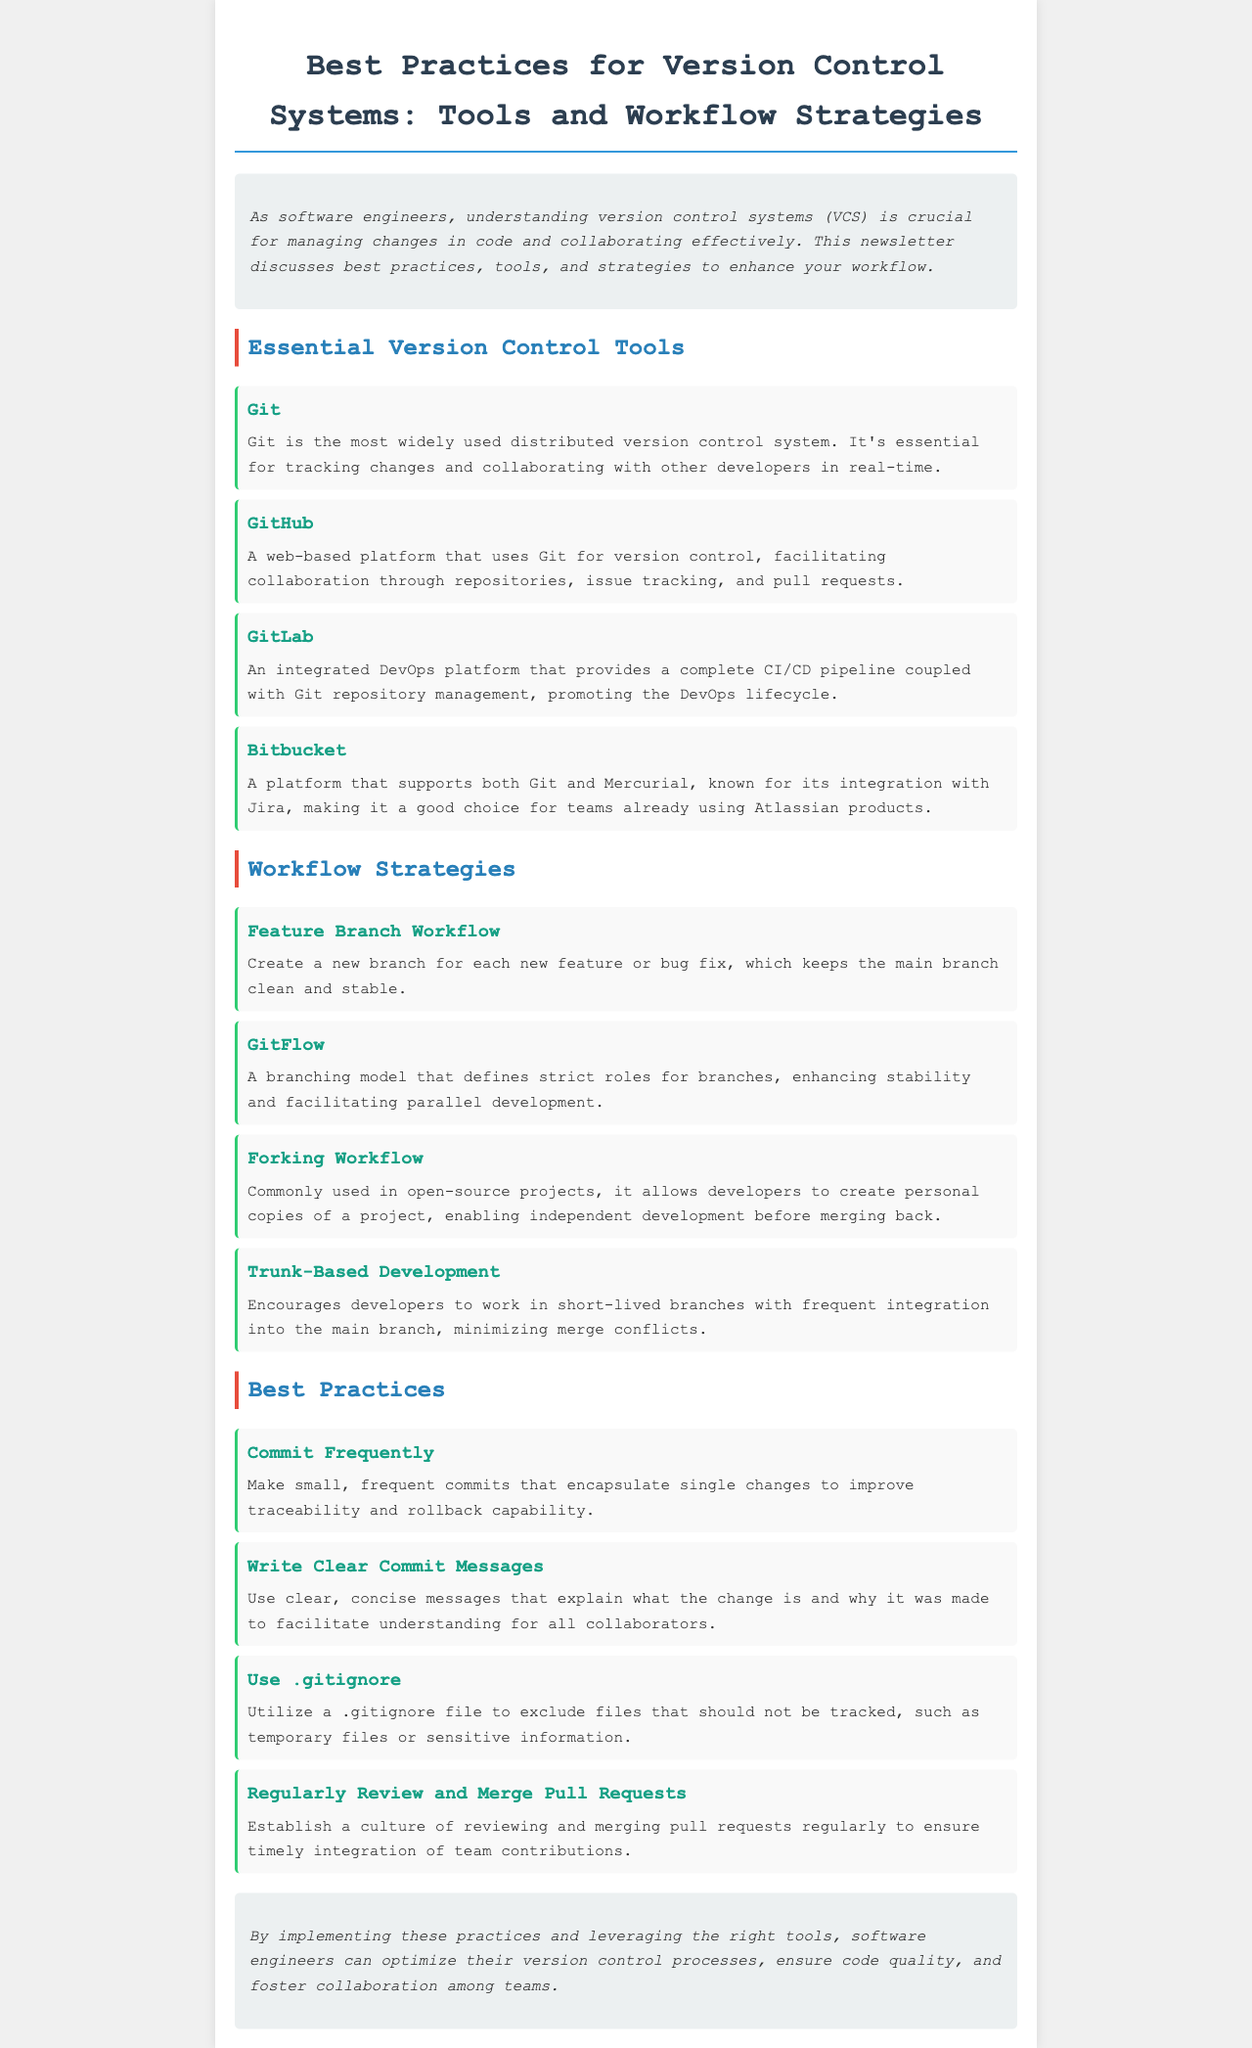What is the title of the newsletter? The title is prominently displayed at the top of the document, clearly stating its purpose and focus.
Answer: Best Practices for Version Control Systems: Tools and Workflow Strategies What is one essential version control tool mentioned in the document? The document lists essential tools under a specific section focused on version control tools.
Answer: Git Which workflow strategy encourages short-lived branches? This strategy is part of the workflow strategies discussed in the document, aimed at minimizing merge conflicts.
Answer: Trunk-Based Development What should commit messages be according to best practices? The document provides guidance on the format and purpose of commit messages under best practices.
Answer: Clear and concise How many main workflow strategies are mentioned? The number of strategies is indicated by the section discussing workflow strategies, which lists them.
Answer: Four 